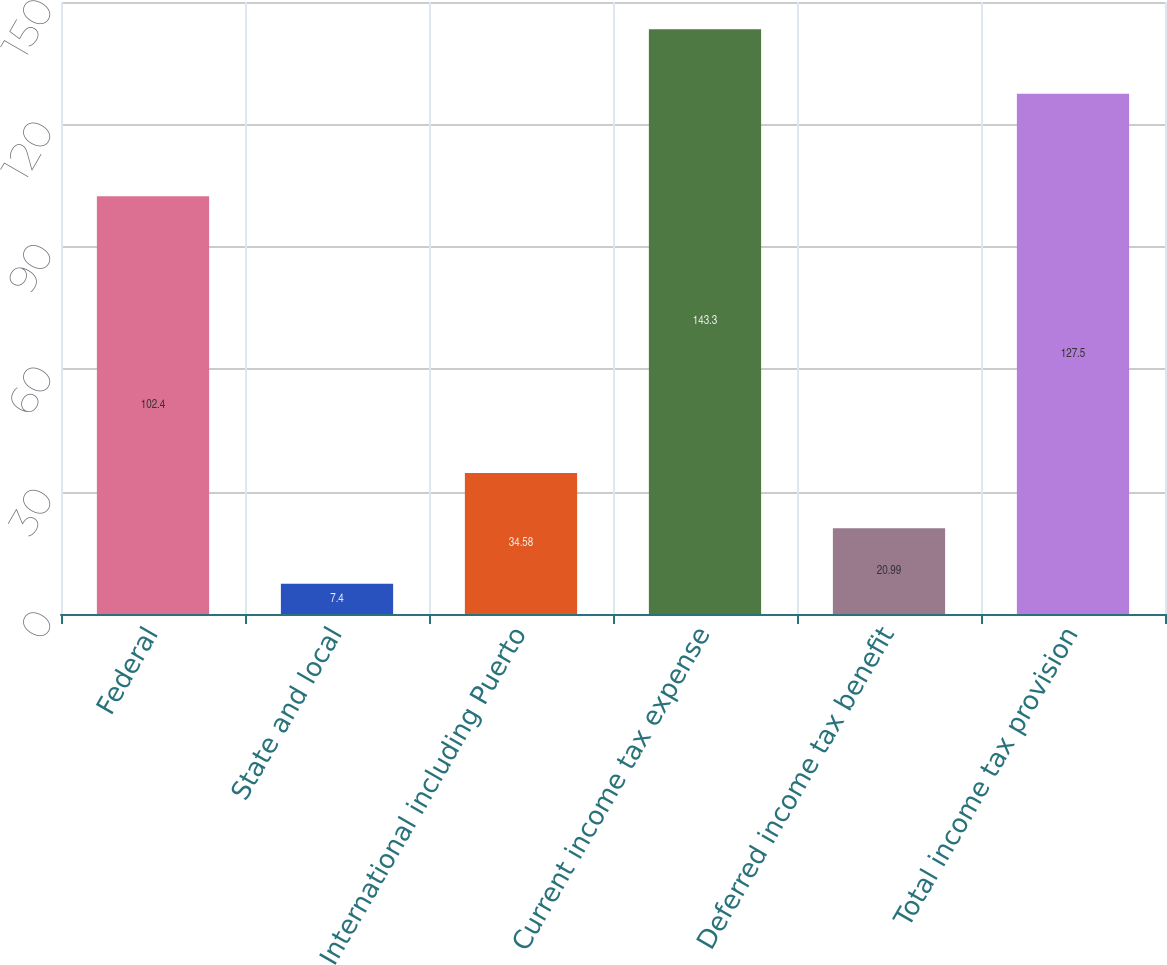<chart> <loc_0><loc_0><loc_500><loc_500><bar_chart><fcel>Federal<fcel>State and local<fcel>International including Puerto<fcel>Current income tax expense<fcel>Deferred income tax benefit<fcel>Total income tax provision<nl><fcel>102.4<fcel>7.4<fcel>34.58<fcel>143.3<fcel>20.99<fcel>127.5<nl></chart> 